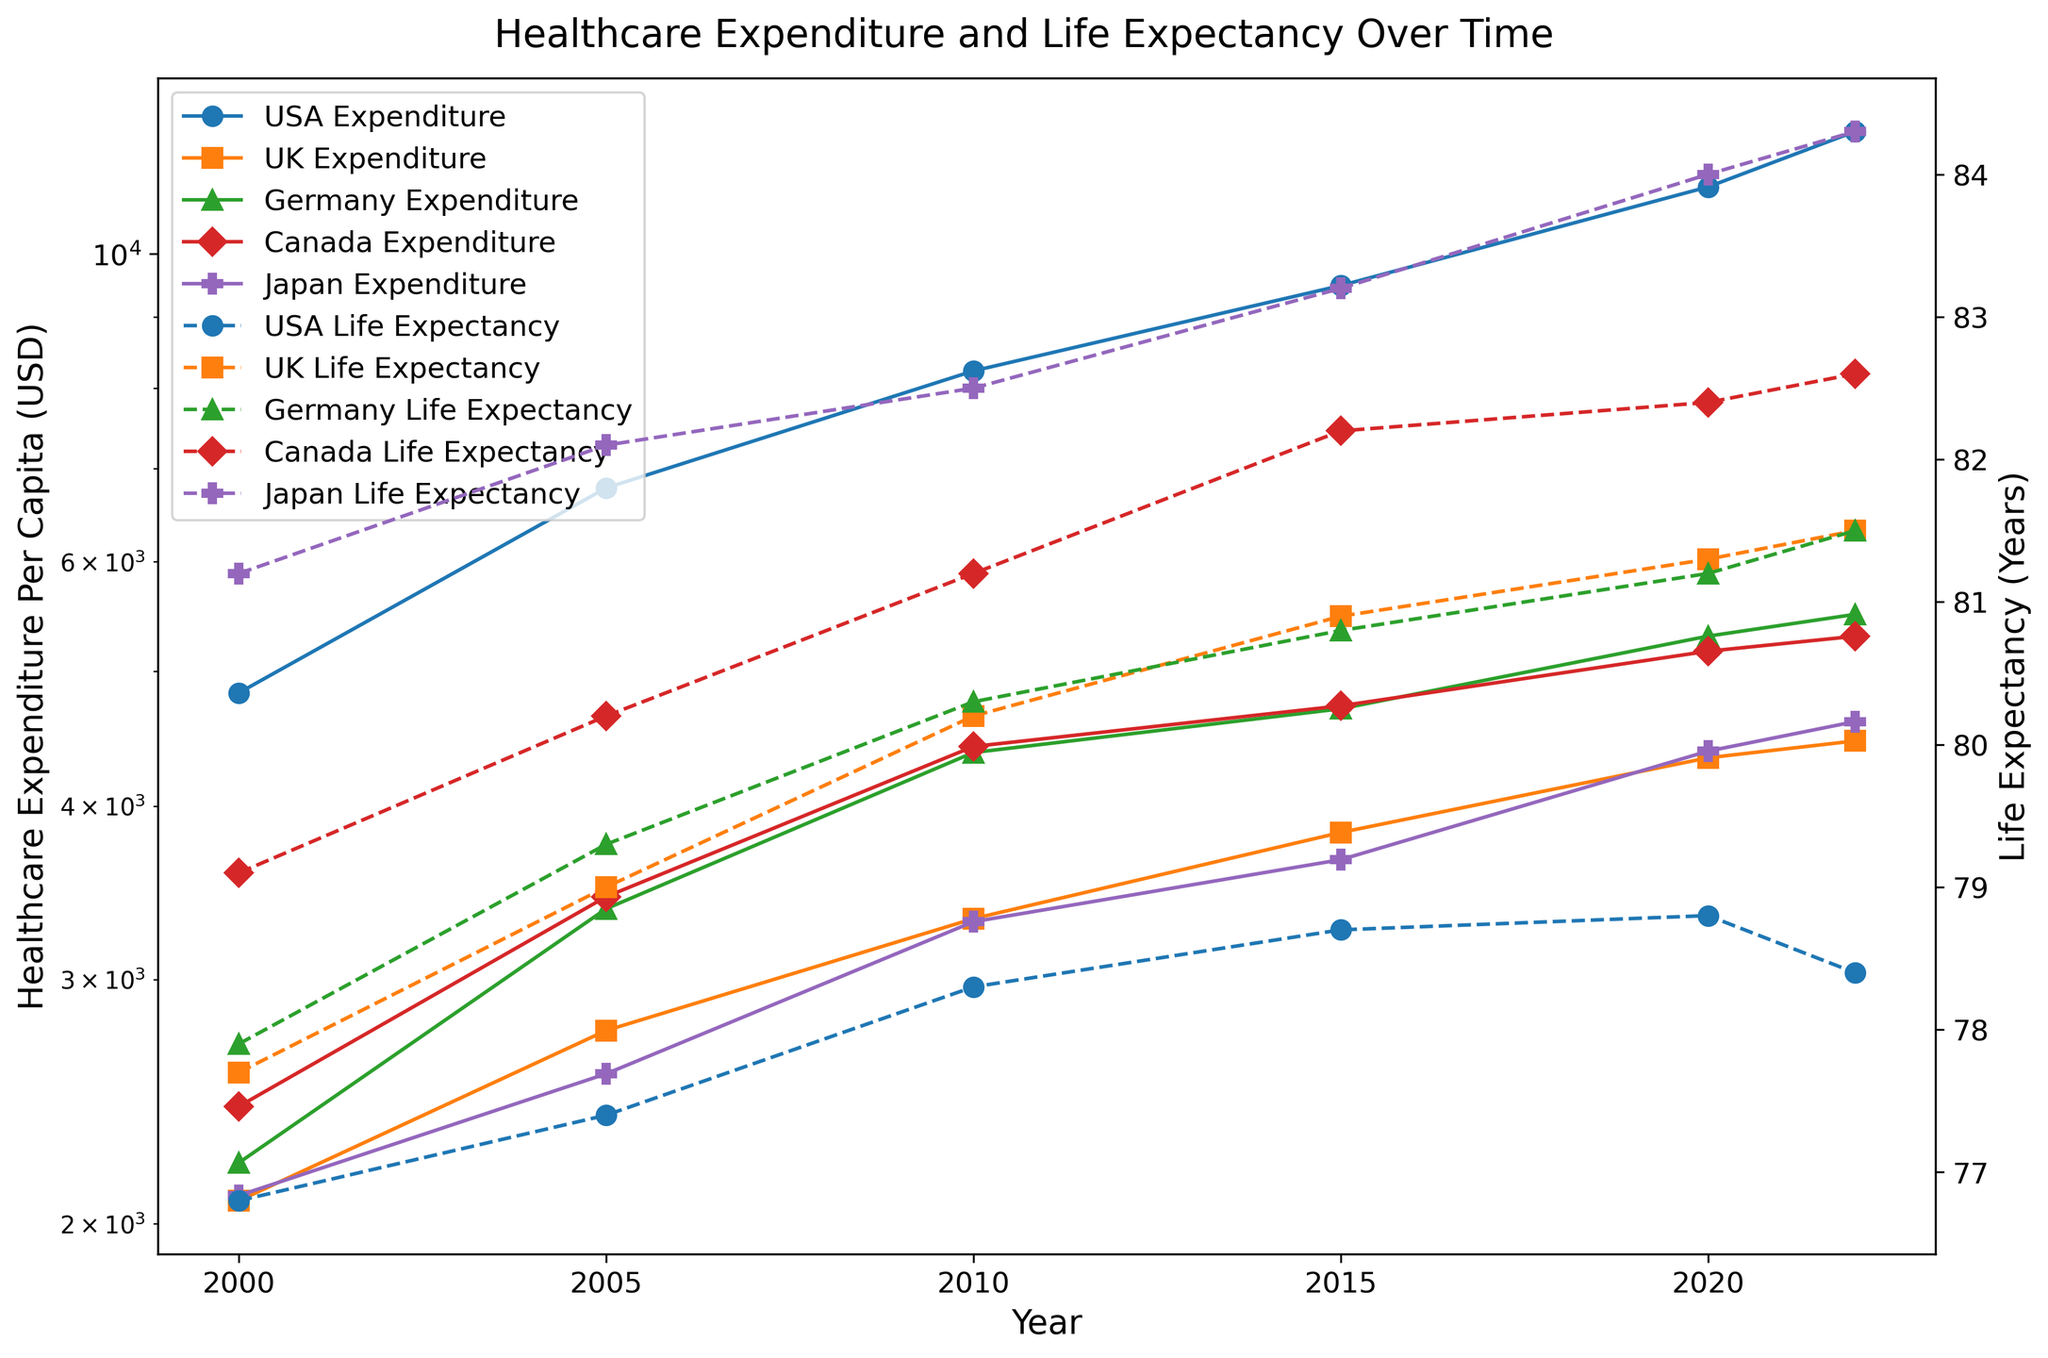What is the general trend in healthcare expenditure per capita in the USA from 2000 to 2022? Observing the solid line with markers assigned to the USA's healthcare expenditure, there is a consistent increase in the per capita expenditure from 2000 to 2022. The expenditure rises from $4,826 in 2000 to $12,247 in 2022.
Answer: An increasing trend Which country had the highest life expectancy in 2022, and what was it? By comparing the dashed lines for life expectancy in 2022, Japan had the highest life expectancy, indicated by the topmost dashed line, at 84.3 years.
Answer: Japan, 84.3 years How does the increase in healthcare expenditure per capita from 2000 to 2022 in the UK compare to the USA? To compare, look at the solid lines for the UK and USA across the years. For the UK, the expenditure increased from $2,078 in 2000 to $4,456 in 2022. For the USA, it increased from $4,826 in 2000 to $12,247 in 2022. The USA's increase is significantly greater.
Answer: The USA had a much larger increase Among the five countries, which one had the smallest change in life expectancy from 2000 to 2022? By observing the change in position of the dashed lines over the years for each country, the USA had the smallest change in life expectancy, increasing only 1.6 years from 76.8 in 2000 to 78.4 in 2022.
Answer: USA In which year did Canada experience the highest increase in healthcare expenditure per capita compared to the previous period? Comparing the solid lines for Canada, the increase from 2000 to 2005 was $1,011, from 2005 to 2010 was $974, from 2010 to 2015 was $308, from 2015 to 2020 was $448, and from 2020 to 2022 was $130. The highest increase occurred from 2000 to 2005.
Answer: 2000 to 2005 Which country had a higher life expectancy in 2010, Germany or the UK, and what were their corresponding values? By comparing the dashed lines for life expectancy in 2010, Germany had a slightly higher life expectancy than the UK. Germany's life expectancy was 80.3 years while the UK's was 80.2 years.
Answer: Germany, 80.3 years What is the difference in life expectancy between Japan and the USA in 2022? By looking at the respective dashed lines in 2022, Japan's life expectancy is 84.3 years and the USA's is 78.4 years. Subtract the USA's value from Japan's. The difference is 84.3 - 78.4 = 5.9 years.
Answer: 5.9 years Has the life expectancy in Canada increased or decreased between 2015 and 2022, and by how much? By observing the dashed line for Canada, life expectancy increased from 82.2 years in 2015 to 82.6 years in 2022. The increase is 82.6 - 82.2 = 0.4 years.
Answer: Increased, by 0.4 years Which countries saw a decrease in life expectancy between 2020 and 2022? Check the dashed lines for each country between 2020 and 2022. The USA is the only country that saw a decrease in life expectancy, dropping from 78.8 in 2020 to 78.4 in 2022.
Answer: USA 